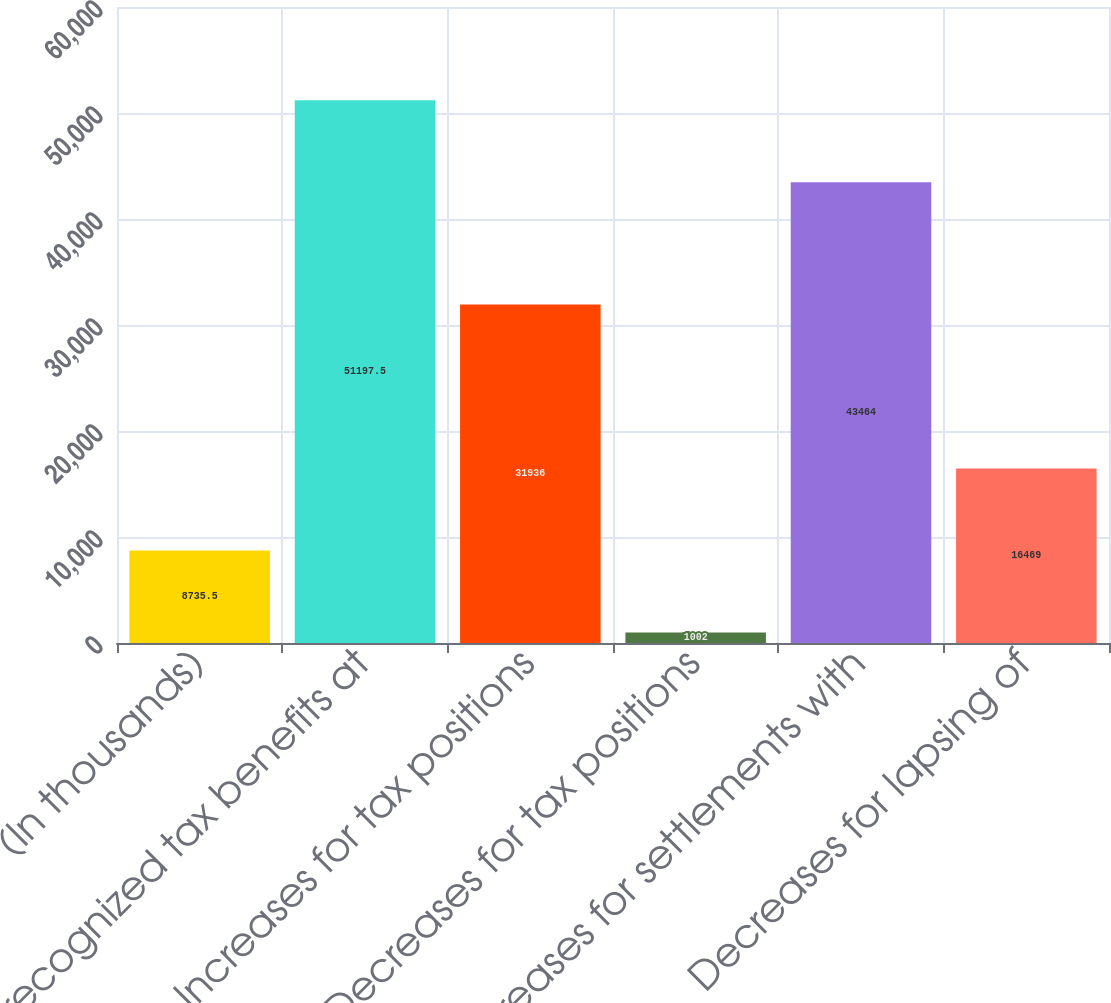<chart> <loc_0><loc_0><loc_500><loc_500><bar_chart><fcel>(In thousands)<fcel>Unrecognized tax benefits at<fcel>Increases for tax positions<fcel>Decreases for tax positions<fcel>Decreases for settlements with<fcel>Decreases for lapsing of<nl><fcel>8735.5<fcel>51197.5<fcel>31936<fcel>1002<fcel>43464<fcel>16469<nl></chart> 